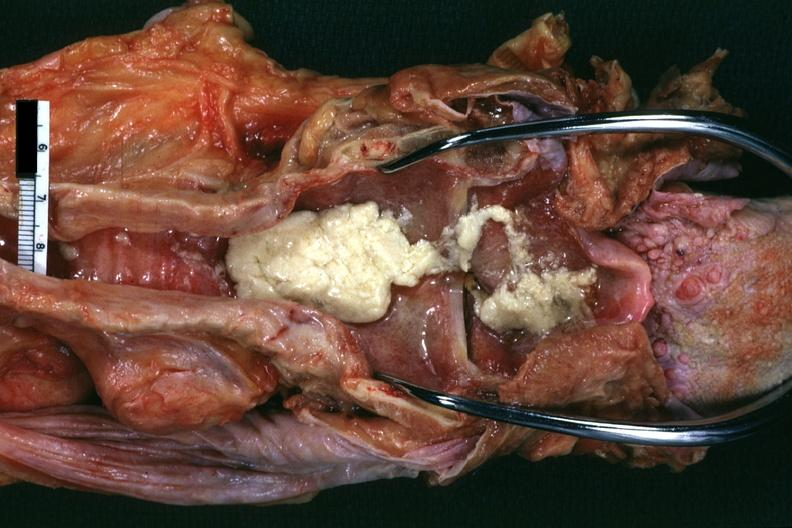where is this?
Answer the question using a single word or phrase. Oral 